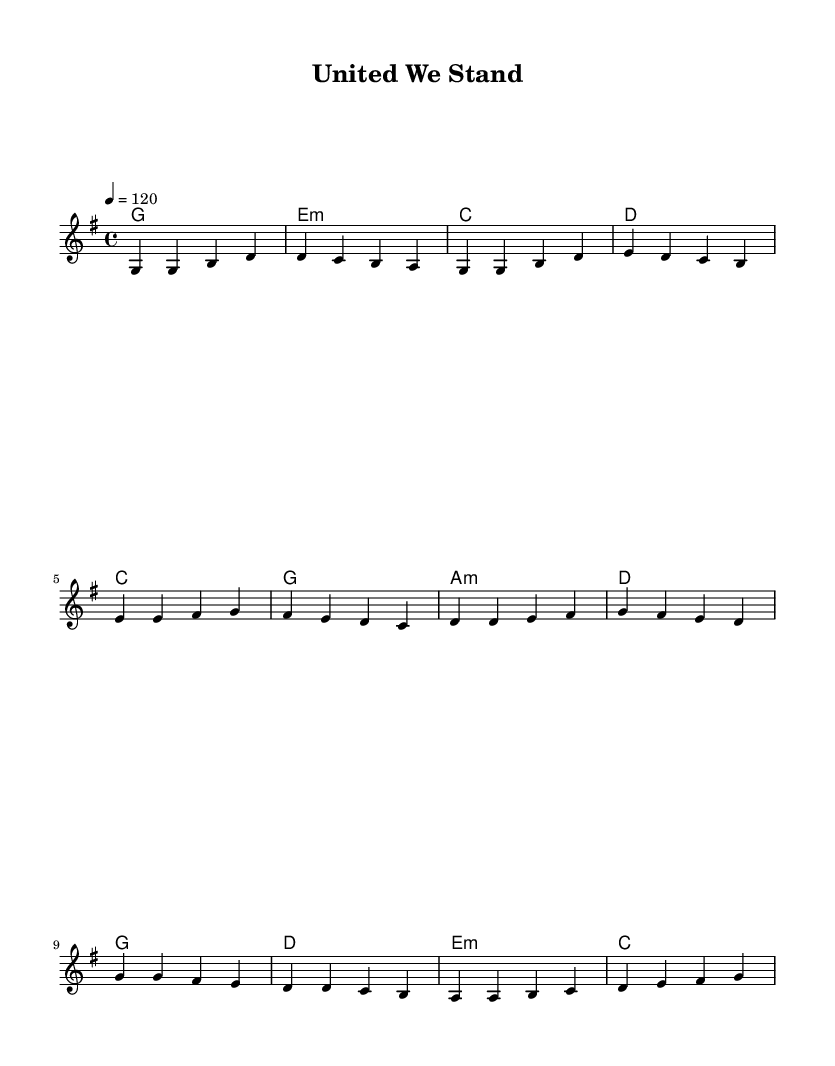What is the key signature of this music? The key signature is G major, which has one sharp (F#). This is indicated at the beginning of the staff.
Answer: G major What is the time signature of this music? The time signature is 4/4, as indicated in the beginning of the score. This means there are four beats in each measure and the quarter note gets one beat.
Answer: 4/4 What is the tempo marking for this piece? The tempo marking is 120 beats per minute, which is noted at the beginning as "4 = 120". This indicates the speed at which the music should be played.
Answer: 120 How many measures are in the chorus section? The chorus comprises four measures, as can be counted in the provided melody and harmonies lines. Each set of four bars corresponds to the chorus lyrics.
Answer: 4 What is the primary theme of the lyrics? The primary theme of the lyrics focuses on unity and strength in overcoming challenges together, which is a hallmark of K-Pop anthems emphasizing teamwork.
Answer: Unity and strength Which chord appears most frequently in the verse? The chord that appears most frequently in the verse is G major, as it is the first chord alternative and is repeated multiple times.
Answer: G major What emotion do the lyrics evoke in this K-Pop anthem? The lyrics evoke feelings of hope and determination, which are common emotions in K-Pop songs focusing on teamwork and collective resilience.
Answer: Hope and determination 